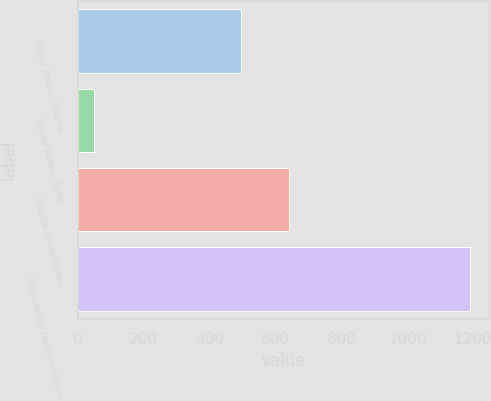Convert chart. <chart><loc_0><loc_0><loc_500><loc_500><bar_chart><fcel>United States - Federal<fcel>United States - State<fcel>Outside United States<fcel>Consolidated taxes on income<nl><fcel>495<fcel>49<fcel>641<fcel>1190<nl></chart> 